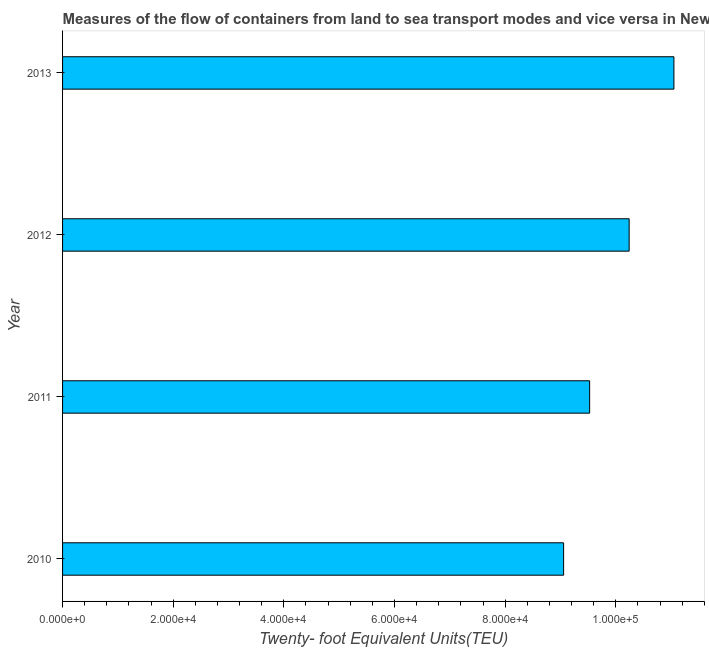Does the graph contain grids?
Keep it short and to the point. No. What is the title of the graph?
Your answer should be very brief. Measures of the flow of containers from land to sea transport modes and vice versa in New Caledonia. What is the label or title of the X-axis?
Provide a short and direct response. Twenty- foot Equivalent Units(TEU). What is the container port traffic in 2013?
Your response must be concise. 1.11e+05. Across all years, what is the maximum container port traffic?
Your answer should be very brief. 1.11e+05. Across all years, what is the minimum container port traffic?
Your answer should be very brief. 9.06e+04. What is the sum of the container port traffic?
Give a very brief answer. 3.99e+05. What is the difference between the container port traffic in 2011 and 2013?
Make the answer very short. -1.52e+04. What is the average container port traffic per year?
Offer a very short reply. 9.97e+04. What is the median container port traffic?
Offer a very short reply. 9.88e+04. In how many years, is the container port traffic greater than 24000 TEU?
Your answer should be compact. 4. Do a majority of the years between 2010 and 2013 (inclusive) have container port traffic greater than 100000 TEU?
Your answer should be compact. No. What is the ratio of the container port traffic in 2010 to that in 2012?
Offer a terse response. 0.88. Is the container port traffic in 2010 less than that in 2012?
Make the answer very short. Yes. Is the difference between the container port traffic in 2010 and 2013 greater than the difference between any two years?
Your answer should be very brief. Yes. What is the difference between the highest and the second highest container port traffic?
Your response must be concise. 8091.4. Is the sum of the container port traffic in 2011 and 2012 greater than the maximum container port traffic across all years?
Provide a succinct answer. Yes. What is the difference between the highest and the lowest container port traffic?
Provide a short and direct response. 1.99e+04. In how many years, is the container port traffic greater than the average container port traffic taken over all years?
Keep it short and to the point. 2. How many bars are there?
Your answer should be compact. 4. Are all the bars in the graph horizontal?
Offer a very short reply. Yes. Are the values on the major ticks of X-axis written in scientific E-notation?
Give a very brief answer. Yes. What is the Twenty- foot Equivalent Units(TEU) of 2010?
Provide a succinct answer. 9.06e+04. What is the Twenty- foot Equivalent Units(TEU) of 2011?
Provide a succinct answer. 9.53e+04. What is the Twenty- foot Equivalent Units(TEU) of 2012?
Provide a short and direct response. 1.02e+05. What is the Twenty- foot Equivalent Units(TEU) of 2013?
Offer a very short reply. 1.11e+05. What is the difference between the Twenty- foot Equivalent Units(TEU) in 2010 and 2011?
Ensure brevity in your answer.  -4703. What is the difference between the Twenty- foot Equivalent Units(TEU) in 2010 and 2012?
Ensure brevity in your answer.  -1.18e+04. What is the difference between the Twenty- foot Equivalent Units(TEU) in 2010 and 2013?
Ensure brevity in your answer.  -1.99e+04. What is the difference between the Twenty- foot Equivalent Units(TEU) in 2011 and 2012?
Provide a short and direct response. -7145.77. What is the difference between the Twenty- foot Equivalent Units(TEU) in 2011 and 2013?
Ensure brevity in your answer.  -1.52e+04. What is the difference between the Twenty- foot Equivalent Units(TEU) in 2012 and 2013?
Offer a very short reply. -8091.4. What is the ratio of the Twenty- foot Equivalent Units(TEU) in 2010 to that in 2011?
Keep it short and to the point. 0.95. What is the ratio of the Twenty- foot Equivalent Units(TEU) in 2010 to that in 2012?
Keep it short and to the point. 0.88. What is the ratio of the Twenty- foot Equivalent Units(TEU) in 2010 to that in 2013?
Make the answer very short. 0.82. What is the ratio of the Twenty- foot Equivalent Units(TEU) in 2011 to that in 2013?
Your answer should be very brief. 0.86. What is the ratio of the Twenty- foot Equivalent Units(TEU) in 2012 to that in 2013?
Provide a succinct answer. 0.93. 